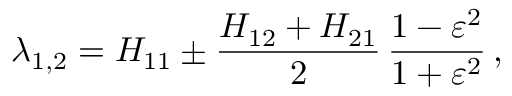<formula> <loc_0><loc_0><loc_500><loc_500>\lambda _ { 1 , 2 } = H _ { 1 1 } \pm \frac { H _ { 1 2 } + H _ { 2 1 } } { 2 } \, \frac { 1 - \varepsilon ^ { 2 } } { 1 + \varepsilon ^ { 2 } } \, ,</formula> 